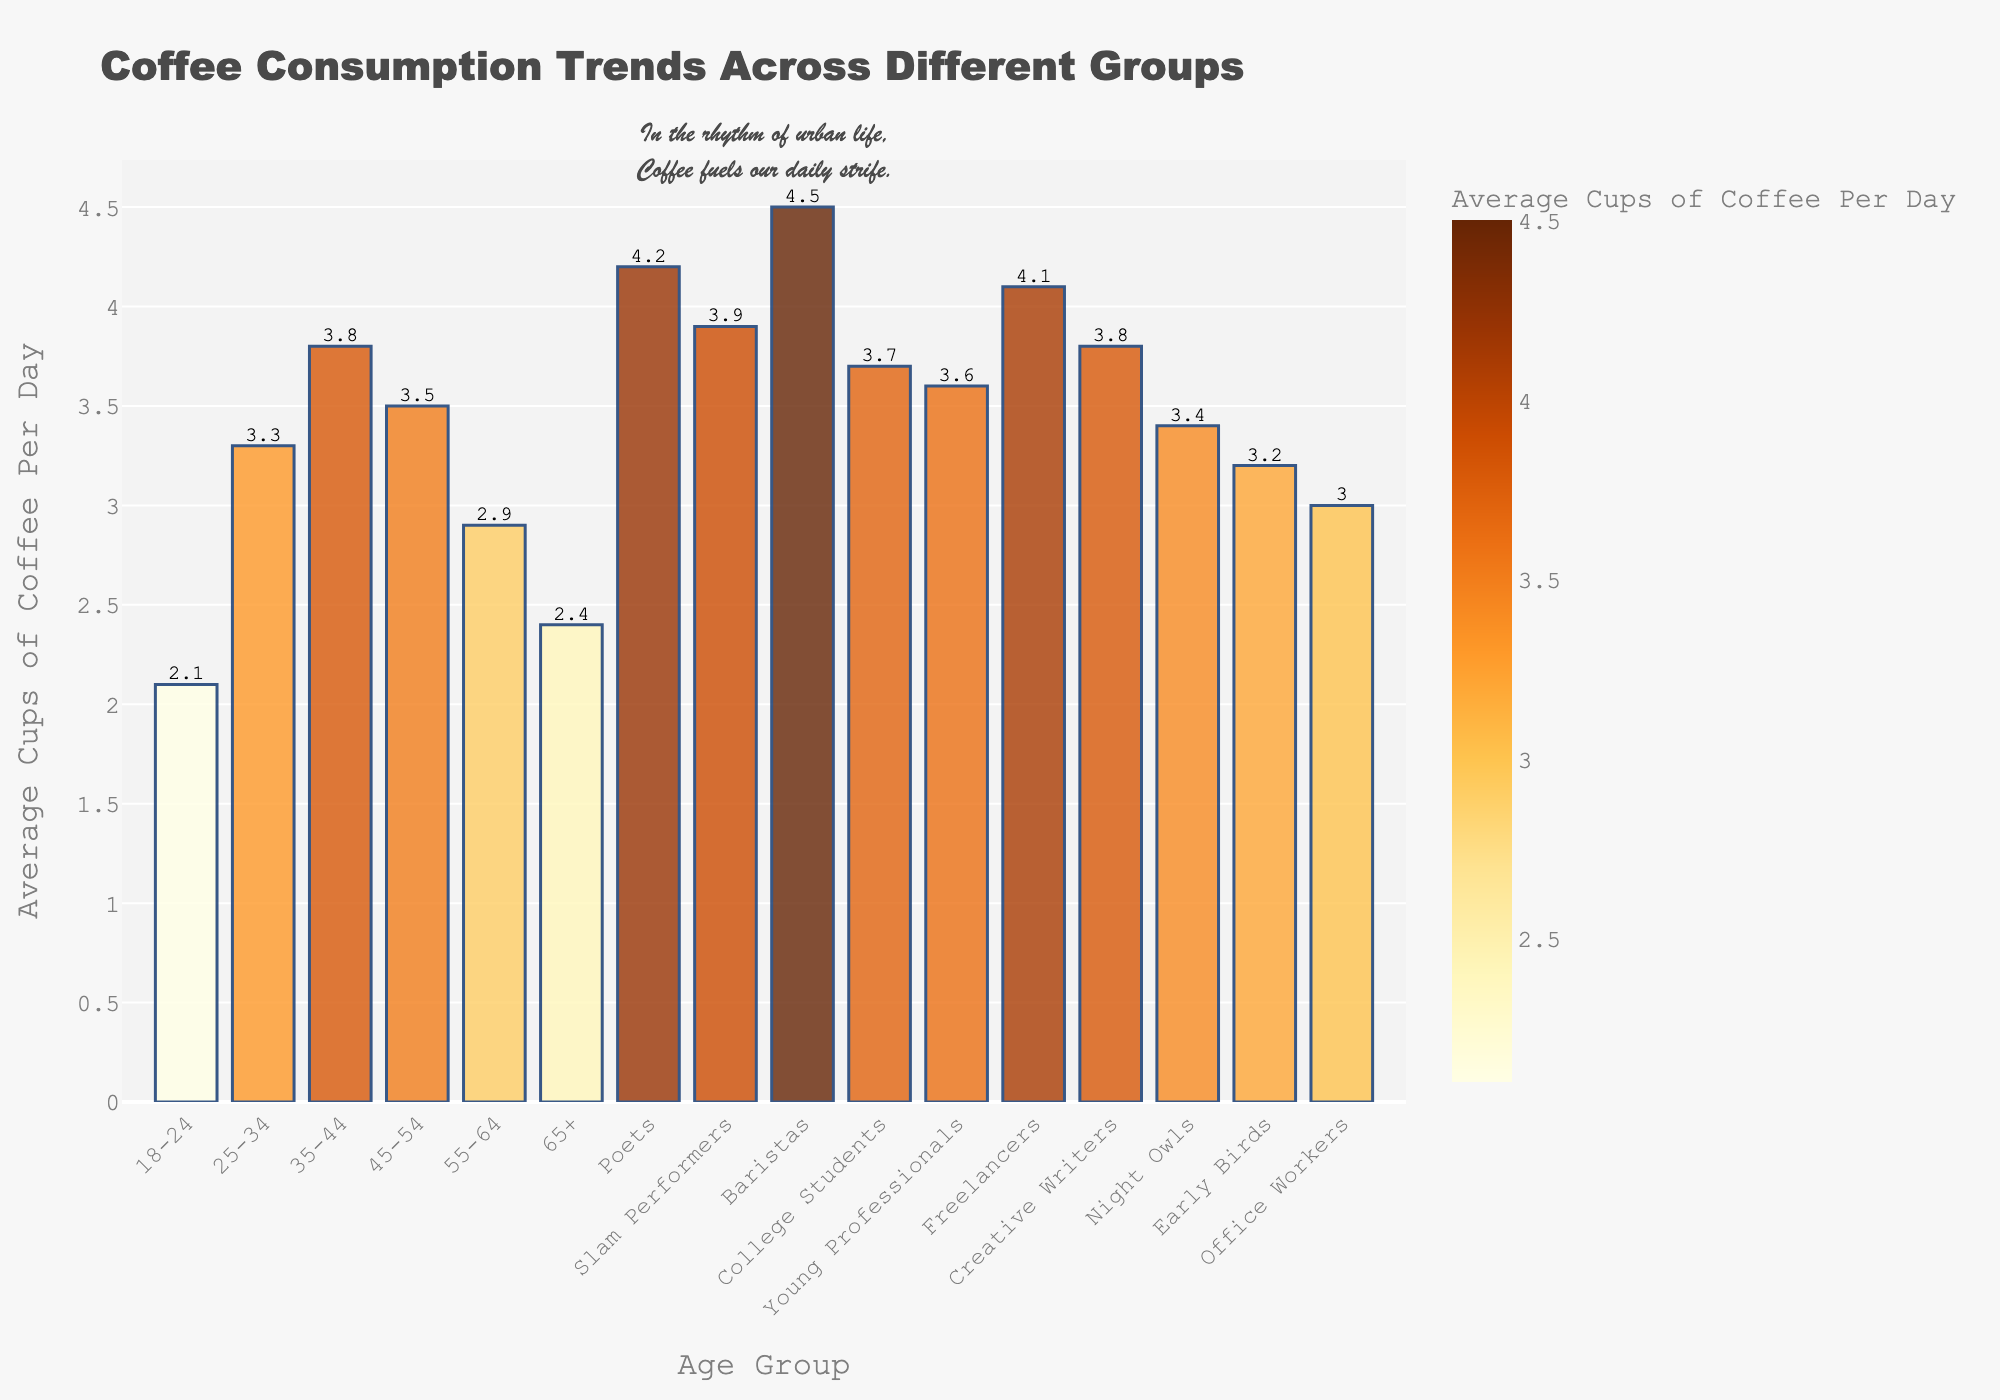What age group has the highest average cups of coffee consumption per day? Looking at the height of the bars, the age group "35-44" has the highest bar, indicating they consume the most at 3.8 average cups per day.
Answer: 35-44 What is the total average cups of coffee consumed per day by baristas, poets, and freelancers combined? Summing the values for Baristas (4.5), Poets (4.2), and Freelancers (4.1): 4.5 + 4.2 + 4.1 = 12.8.
Answer: 12.8 Which has a higher average coffee consumption: Young Professionals or Office Workers? Young Professionals have an average cups per day of 3.6, while Office Workers have 3.0. Therefore, Young Professionals consume more on average.
Answer: Young Professionals Are there any groups with an average cups per day of exactly 3.8? By scanning the plot, Creative Writers and those aged 35-44 both have an average of 3.8 cups per day.
Answer: Yes Which group has the lowest average coffee consumption per day and what is the value? Observing the shortest bar, the age group "18-24" has the lowest consumption at 2.1 average cups per day.
Answer: 18-24, 2.1 How does the average coffee consumption of Baristas compare to College Students? Baristas consume an average of 4.5 cups per day, whereas College Students consume 3.7 cups per day. Thus, Baristas drink more coffee on average.
Answer: Baristas consume more If we combine the average coffee consumption for Early Birds and Night Owls, what is the result? Early Birds consume 3.2 average cups per day, while Night Owls consume 3.4. Combined, it is 3.2 + 3.4 = 6.6.
Answer: 6.6 Which group consumes more coffee on average: Freelancers or Young Professionals? Freelancers consume an average of 4.1 cups per day, while Young Professionals consume 3.6. Thus, Freelancers consume more coffee on average.
Answer: Freelancers What is the average coffee consumption difference between Poets and Office Workers? Poets consume 4.2 average cups per day, and Office Workers consume 3.0. The difference is 4.2 - 3.0 = 1.2.
Answer: 1.2 